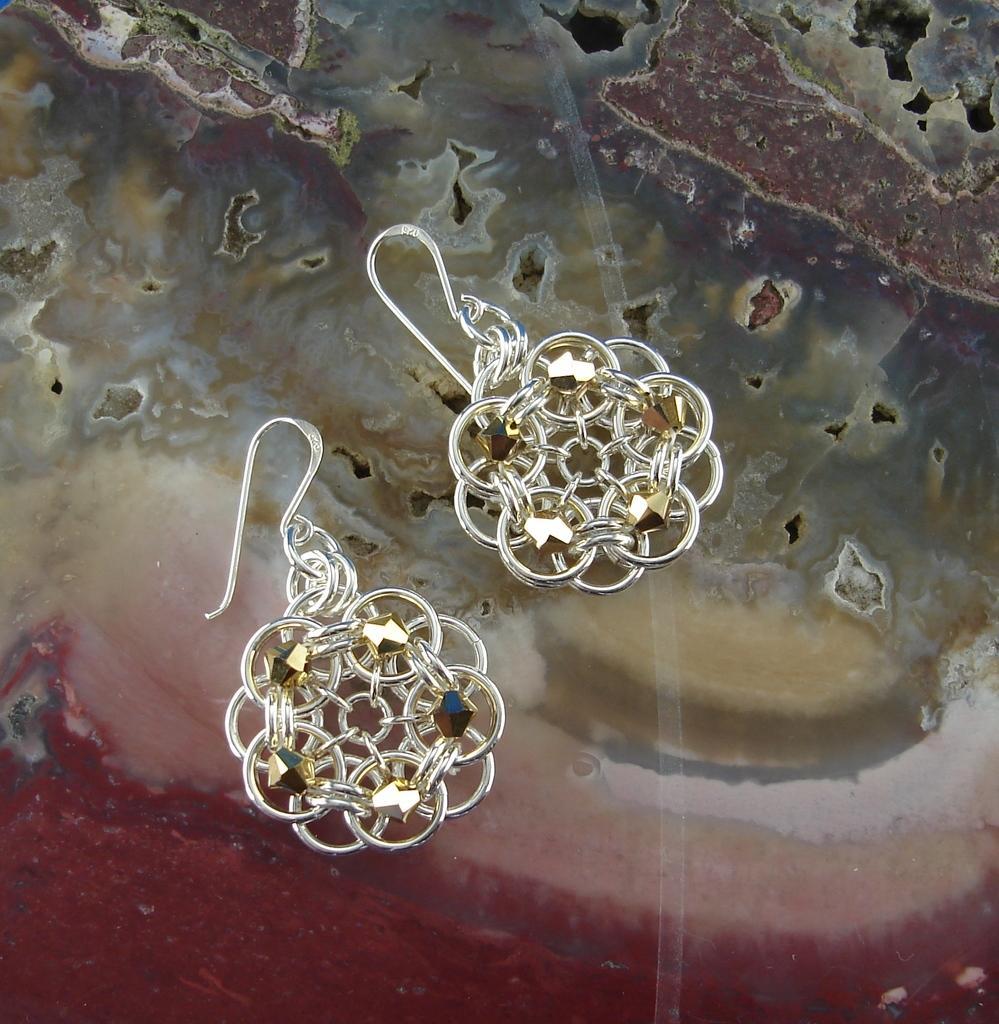How would you summarize this image in a sentence or two? In the image, we can see a pair of earrings with a gold color stones. 